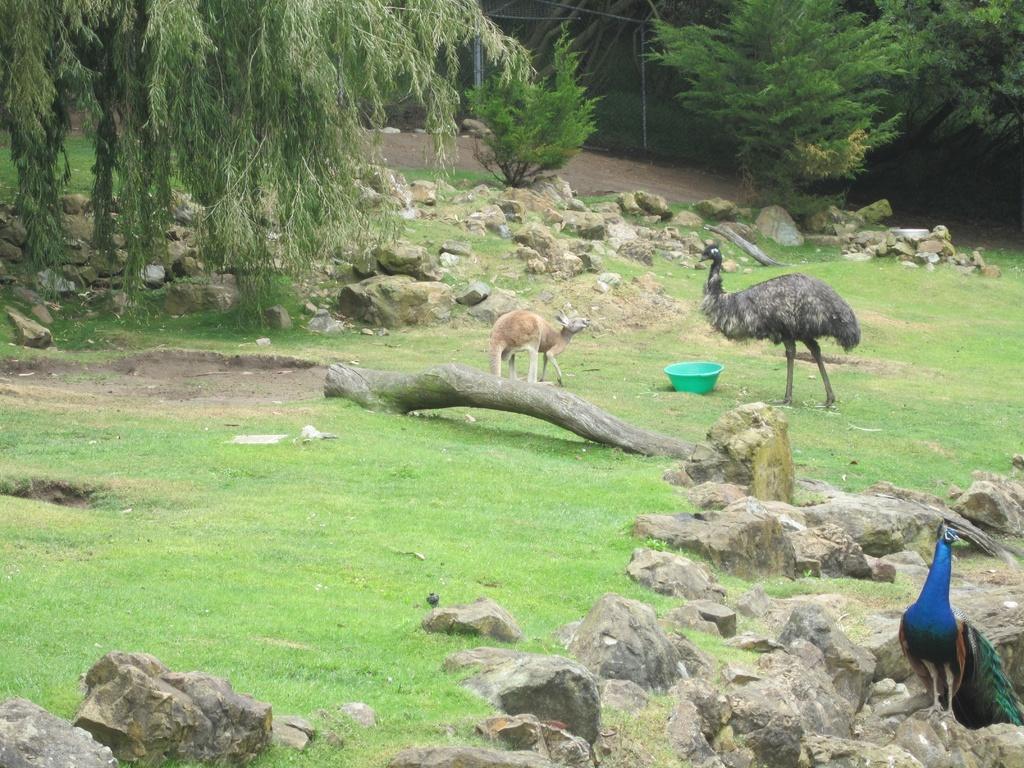How would you summarize this image in a sentence or two? This is an outside view. At the bottom of the image I can see the grass and some rocks. On the right side there is a peacock. In the middle of the image I can see an ostrich bird and an animal which is standing in front of this bird and also there is a basket. Beside these there is a trunk on the ground. In the background there are some trees and rocks on the ground. 